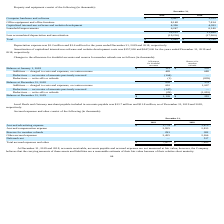From Travelzoo's financial document, What is the accrued advertising expense for 2019 and 2018 respectively? The document shows two values: $1,774 and $1,875 (in thousands). From the document: "Accrued advertising expense $ 1,774 $ 1,875 Accrued advertising expense $ 1,774 $ 1,875..." Also, What is the accrued compensation expense for 2019 and 2018 respectively? The document shows two values: 2,955 and 2,813 (in thousands). From the document: "Accrued compensation expense 2,955 2,813 Accrued compensation expense 2,955 2,813..." Also, What is the reserve for member refunds for 2019 and 2018 respectively? The document shows two values: 293 and 382 (in thousands). From the document: "Reserve for member refunds 293 382 Reserve for member refunds 293 382..." Also, can you calculate: What is the change in accrued compensation expense between 2018 and 2019? Based on the calculation: 2,955-2,813, the result is 142 (in thousands). This is based on the information: "Accrued compensation expense 2,955 2,813 Accrued compensation expense 2,955 2,813..." The key data points involved are: 2,813, 2,955. Also, can you calculate: What is the average reserve for member refunds for 2018 and 2019? To answer this question, I need to perform calculations using the financial data. The calculation is: (293+382)/2, which equals 337.5 (in thousands). This is based on the information: "Reserve for member refunds 293 382 Reserve for member refunds 293 382..." The key data points involved are: 293, 382. Also, can you calculate: What is the percentage change in the total accrued expenses and other from 2018 to 2019? To answer this question, I need to perform calculations using the financial data. The calculation is: (7,477-7,853)/7,853, which equals -4.79 (percentage). This is based on the information: "Total accrued expenses and other $ 7,477 $ 7,853 Total accrued expenses and other $ 7,477 $ 7,853..." The key data points involved are: 7,477, 7,853. 